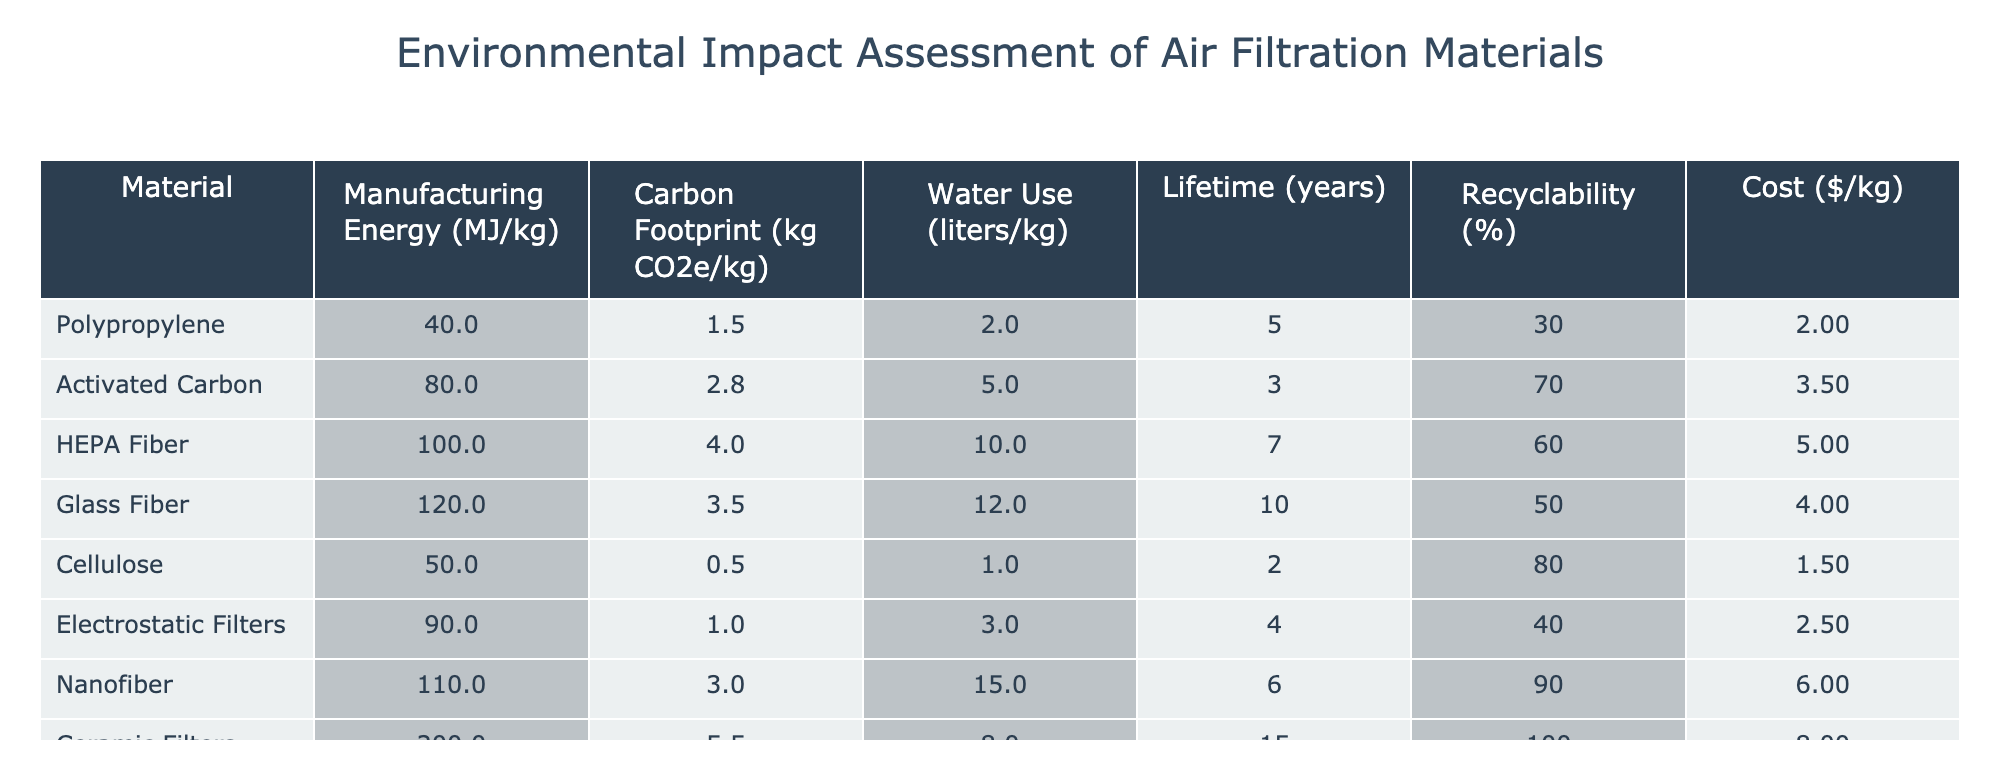What is the manufacturing energy requirement for HEPA Fiber? The table directly shows the manufacturing energy for HEPA Fiber in the 'Manufacturing Energy (MJ/kg)' column. For HEPA Fiber, this value is 100.
Answer: 100 What is the carbon footprint of Activated Carbon? The table indicates that the carbon footprint for Activated Carbon is found in the 'Carbon Footprint (kg CO2e/kg)' column. The value there is 2.8.
Answer: 2.8 Which material has the highest recyclability? By checking the 'Recyclability (%)' column, we find that Ceramic Filters have the highest recyclability at 100%.
Answer: 100% What is the average water use of all the materials listed? First, we sum the water usage values: 2.0 + 5.0 + 10.0 + 12.0 + 1.0 + 3.0 + 15.0 + 8.0 = 56.0 liters. Then, we divide by the number of materials (8) to find the average: 56.0 / 8 = 7.0 liters.
Answer: 7.0 Is it true that Glass Fiber has a lower carbon footprint than Nanofiber? By comparing the values in the ‘Carbon Footprint (kg CO2e/kg)’ column, Glass Fiber has a carbon footprint of 3.5 while Nanofiber has 3.0. Since 3.5 is greater than 3.0, this statement is false.
Answer: False What is the cumulative cost of the three most affordable materials? Checking the 'Cost ($/kg)' column, we find Cellulose (1.50), Polypropylene (2.00), and Electrostatic Filters (2.50). The total cost is 1.50 + 2.00 + 2.50 = 6.00.
Answer: 6.00 How does the lifetime of Ceramic Filters compare to that of Activated Carbon? From the 'Lifetime (years)' column, Ceramic Filters have a lifetime of 15 years while Activated Carbon has a lifetime of 3 years. Since 15 years is greater than 3 years, Ceramic Filters last longer.
Answer: Ceramic Filters last longer What is the difference in manufacturing energy between the highest and lowest energy materials? The maximum manufacturing energy is for Ceramic Filters at 200 MJ/kg, and the minimum is for Cellulose at 50 MJ/kg. The difference is calculated as 200 - 50 = 150 MJ/kg.
Answer: 150 Which material has the longest lifetime and what is that duration? The 'Lifetime (years)' column reveals that Ceramic Filters have the longest lifetime at 15 years.
Answer: 15 years 